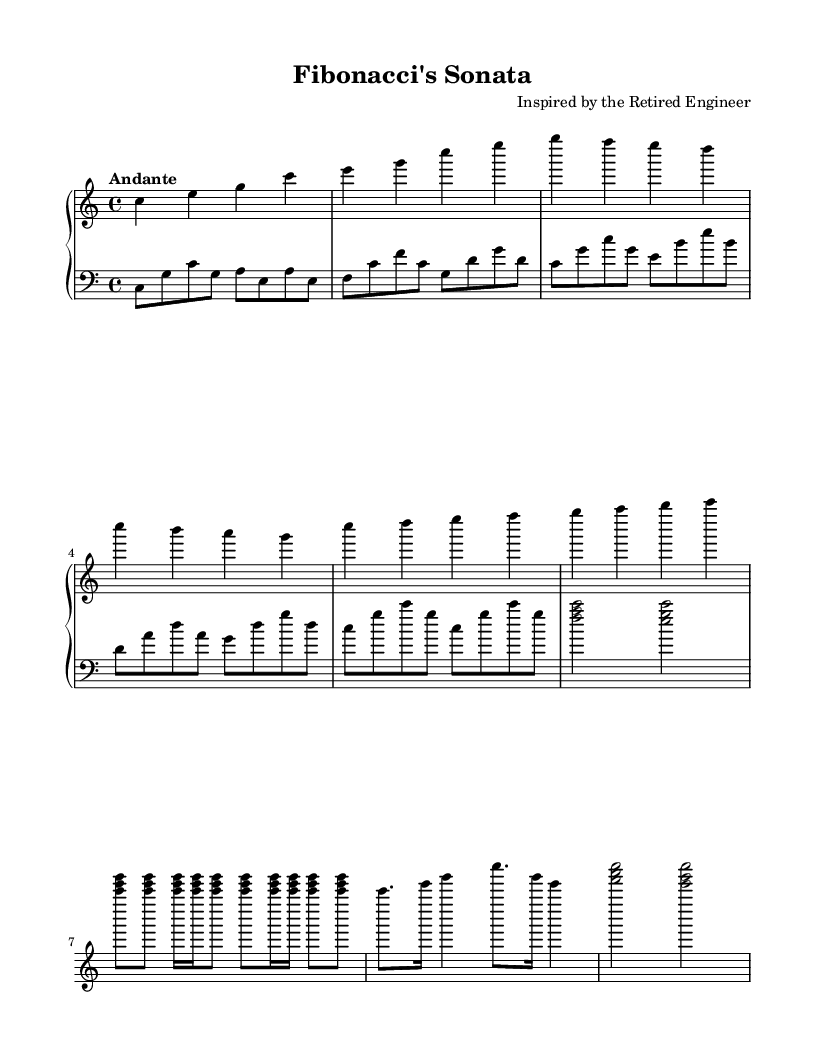What is the key signature of this music? The key signature is C major, which has no sharps or flats.
Answer: C major What is the time signature of this piece? The time signature is 4/4, indicating four beats per measure with a quarter note receiving one beat.
Answer: 4/4 What is the tempo marking for this composition? The tempo marking indicates "Andante", which suggests a moderate pace, often interpreted as walking speed.
Answer: Andante What kind of rhythmic pattern is used in the prime number section? The prime number rhythm incorporates dotted notes and sixteenth notes, creating a complex rhythmic feel.
Answer: Dotted What sequence is incorporated in the melody for the arpeggios? The arpeggios are based on the Fibonacci sequence, which follows a pattern where each number is the sum of the two preceding ones.
Answer: Fibonacci Explain how the main theme relates to Fibonacci's number sequence. The main theme alternates between the notes of a C major triad and repeats certain note durations to reflect the Fibonacci nature of growth, with musical phrases resembling the sequence in their length and structure.
Answer: Melodic structure 